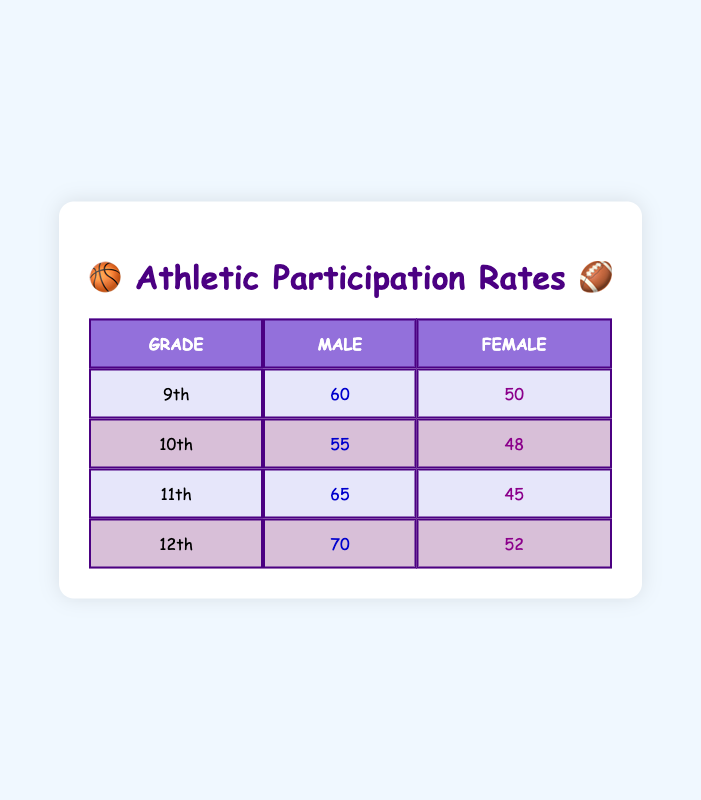What is the total number of male participants in 10th grade? From the table, the number of male participants in 10th grade is 55. There are no additional steps needed as this is a retrieval question that directly references a single cell in the table.
Answer: 55 What is the total number of female participants in 12th grade? The table indicates that there are 52 female participants in 12th grade. This is another retrieval question that refers to a specific cell.
Answer: 52 What grade has the highest number of male participants? To find this, we compare the male participants across each grade: 60 in 9th, 55 in 10th, 65 in 11th, and 70 in 12th. The grade with the highest number is 12th with 70 participants.
Answer: 12th What is the average number of female participants across all grades? We add the number of female participants: 50 (9th) + 48 (10th) + 45 (11th) + 52 (12th) = 195. Then, we divide by the number of grades (4): 195 / 4 = 48.75. So, the average number of female participants is 48.75.
Answer: 48.75 Are there more male participants in 12th grade than there are female participants in 11th grade? The table shows 70 male participants in 12th grade and 45 female participants in 11th grade. Since 70 is greater than 45, the answer is yes.
Answer: Yes In which grade does the difference between male and female participants have the largest value? We calculate the difference for each grade: 9th: 60 - 50 = 10, 10th: 55 - 48 = 7, 11th: 65 - 45 = 20, and 12th: 70 - 52 = 18. The largest difference is 20 in 11th grade.
Answer: 11th What percentage of participants in 9th grade are female? There are 50 female participants and 60 male participants in 9th grade. Total participants = 60 + 50 = 110. The percentage of female participants is (50 / 110) * 100 ≈ 45.45%.
Answer: 45.45% Is the number of male participants in 11th grade greater than the number of total female participants in 10th and 12th combined? The number of male participants in 11th grade is 65. The total number of female participants in 10th (48) and 12th (52) grades is 48 + 52 = 100. Since 65 is less than 100, the answer is no.
Answer: No What is the total number of athletic participants across all grades? We sum all participants in the table: 60 (9M) + 50 (9F) + 55 (10M) + 48 (10F) + 65 (11M) + 45 (11F) + 70 (12M) + 52 (12F) = 400.
Answer: 400 